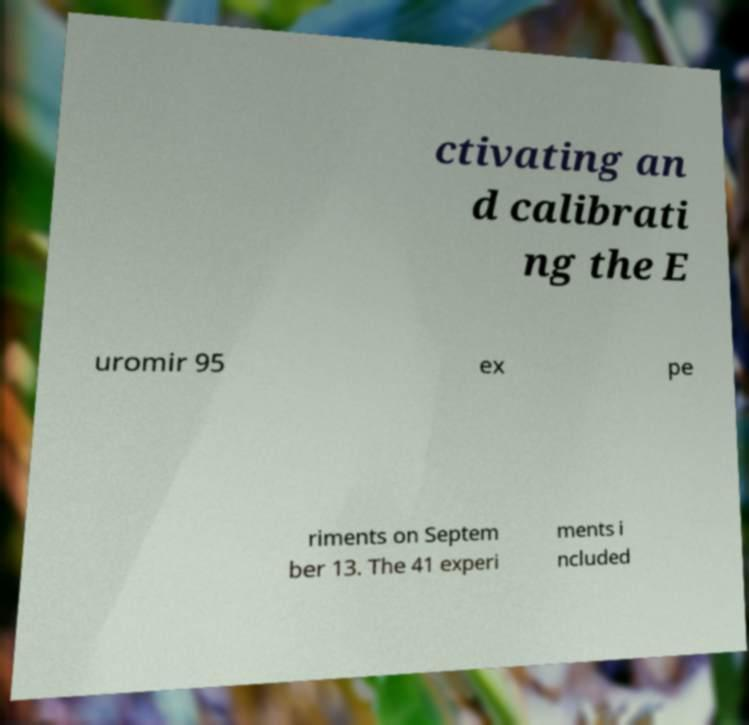Can you accurately transcribe the text from the provided image for me? ctivating an d calibrati ng the E uromir 95 ex pe riments on Septem ber 13. The 41 experi ments i ncluded 